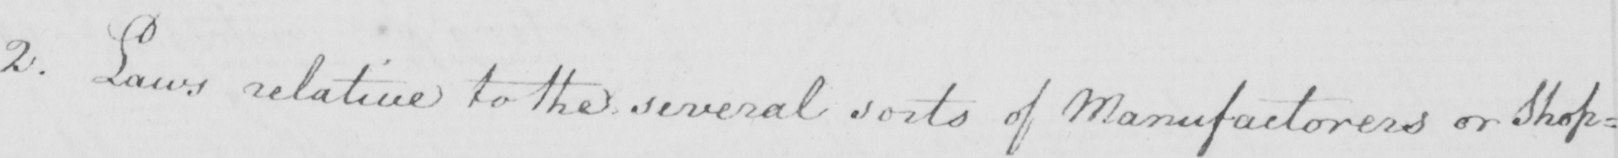Can you read and transcribe this handwriting? 2. Laws relative to the several sorts of Manufactorers or Shop= 